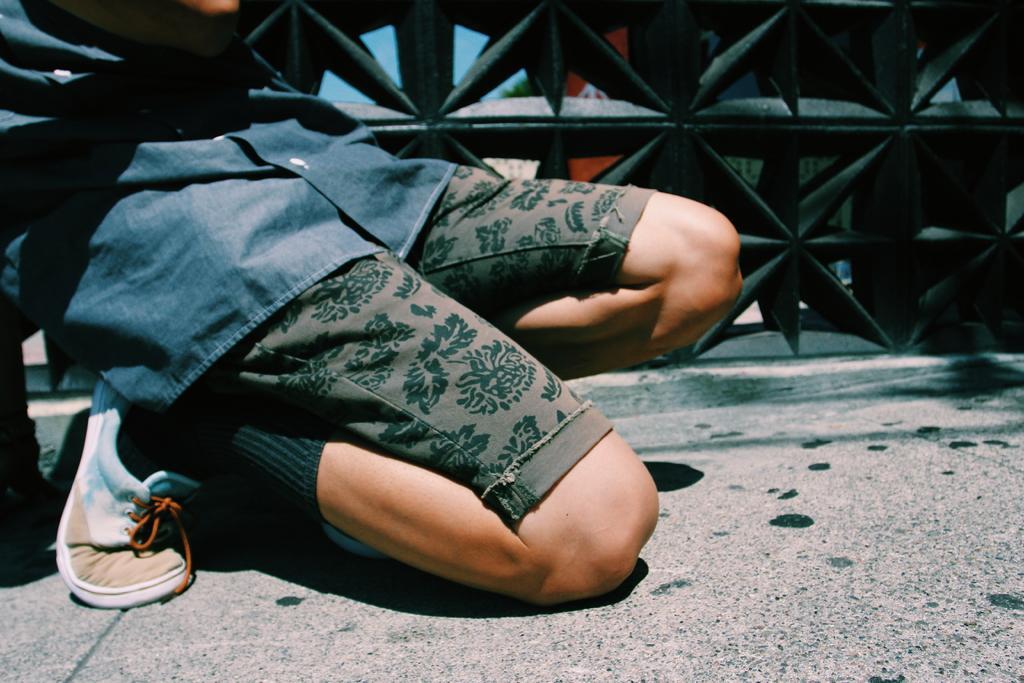Please provide a concise description of this image. This image consists of a man sitting on the knees. At the bottom, there is a road. In the background, we can see a railing in black color. He is wearing a blue shirt. 